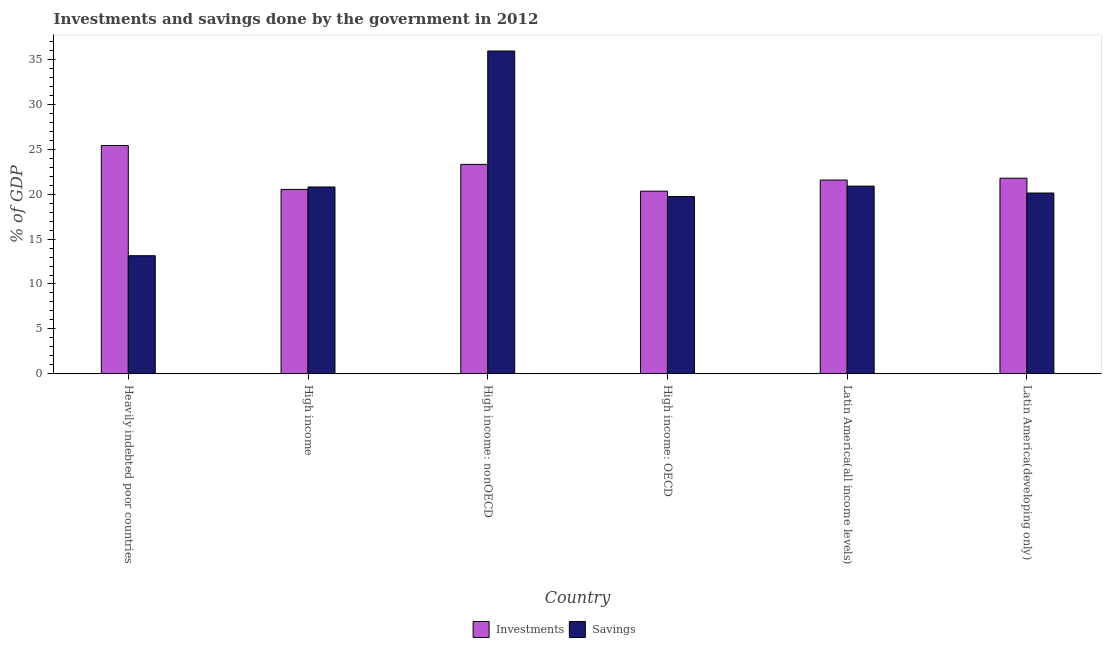Are the number of bars on each tick of the X-axis equal?
Ensure brevity in your answer.  Yes. What is the label of the 6th group of bars from the left?
Provide a succinct answer. Latin America(developing only). What is the investments of government in High income: nonOECD?
Offer a terse response. 23.33. Across all countries, what is the maximum investments of government?
Provide a short and direct response. 25.43. Across all countries, what is the minimum savings of government?
Your response must be concise. 13.15. In which country was the savings of government maximum?
Offer a very short reply. High income: nonOECD. In which country was the savings of government minimum?
Ensure brevity in your answer.  Heavily indebted poor countries. What is the total investments of government in the graph?
Your response must be concise. 133.02. What is the difference between the investments of government in High income and that in Latin America(all income levels)?
Give a very brief answer. -1.04. What is the difference between the investments of government in Heavily indebted poor countries and the savings of government in High income?
Ensure brevity in your answer.  4.62. What is the average investments of government per country?
Your answer should be compact. 22.17. What is the difference between the investments of government and savings of government in Heavily indebted poor countries?
Ensure brevity in your answer.  12.28. What is the ratio of the investments of government in Latin America(all income levels) to that in Latin America(developing only)?
Provide a short and direct response. 0.99. Is the savings of government in Heavily indebted poor countries less than that in High income?
Your response must be concise. Yes. Is the difference between the investments of government in Heavily indebted poor countries and High income: nonOECD greater than the difference between the savings of government in Heavily indebted poor countries and High income: nonOECD?
Make the answer very short. Yes. What is the difference between the highest and the second highest savings of government?
Your response must be concise. 15.06. What is the difference between the highest and the lowest savings of government?
Your response must be concise. 22.81. In how many countries, is the investments of government greater than the average investments of government taken over all countries?
Offer a very short reply. 2. What does the 2nd bar from the left in Latin America(developing only) represents?
Your answer should be compact. Savings. What does the 1st bar from the right in Latin America(all income levels) represents?
Your answer should be compact. Savings. What is the difference between two consecutive major ticks on the Y-axis?
Make the answer very short. 5. Does the graph contain grids?
Provide a short and direct response. No. How are the legend labels stacked?
Ensure brevity in your answer.  Horizontal. What is the title of the graph?
Your response must be concise. Investments and savings done by the government in 2012. What is the label or title of the Y-axis?
Offer a terse response. % of GDP. What is the % of GDP in Investments in Heavily indebted poor countries?
Offer a very short reply. 25.43. What is the % of GDP of Savings in Heavily indebted poor countries?
Keep it short and to the point. 13.15. What is the % of GDP of Investments in High income?
Give a very brief answer. 20.54. What is the % of GDP of Savings in High income?
Your answer should be compact. 20.81. What is the % of GDP in Investments in High income: nonOECD?
Provide a succinct answer. 23.33. What is the % of GDP of Savings in High income: nonOECD?
Make the answer very short. 35.96. What is the % of GDP of Investments in High income: OECD?
Ensure brevity in your answer.  20.34. What is the % of GDP of Savings in High income: OECD?
Keep it short and to the point. 19.74. What is the % of GDP of Investments in Latin America(all income levels)?
Make the answer very short. 21.58. What is the % of GDP of Savings in Latin America(all income levels)?
Offer a very short reply. 20.91. What is the % of GDP in Investments in Latin America(developing only)?
Provide a short and direct response. 21.79. What is the % of GDP in Savings in Latin America(developing only)?
Give a very brief answer. 20.14. Across all countries, what is the maximum % of GDP in Investments?
Keep it short and to the point. 25.43. Across all countries, what is the maximum % of GDP in Savings?
Your response must be concise. 35.96. Across all countries, what is the minimum % of GDP of Investments?
Give a very brief answer. 20.34. Across all countries, what is the minimum % of GDP in Savings?
Make the answer very short. 13.15. What is the total % of GDP in Investments in the graph?
Provide a short and direct response. 133.02. What is the total % of GDP in Savings in the graph?
Your answer should be very brief. 130.71. What is the difference between the % of GDP in Investments in Heavily indebted poor countries and that in High income?
Your answer should be very brief. 4.89. What is the difference between the % of GDP of Savings in Heavily indebted poor countries and that in High income?
Ensure brevity in your answer.  -7.66. What is the difference between the % of GDP of Investments in Heavily indebted poor countries and that in High income: nonOECD?
Provide a short and direct response. 2.1. What is the difference between the % of GDP in Savings in Heavily indebted poor countries and that in High income: nonOECD?
Make the answer very short. -22.81. What is the difference between the % of GDP in Investments in Heavily indebted poor countries and that in High income: OECD?
Offer a terse response. 5.09. What is the difference between the % of GDP in Savings in Heavily indebted poor countries and that in High income: OECD?
Your answer should be very brief. -6.59. What is the difference between the % of GDP in Investments in Heavily indebted poor countries and that in Latin America(all income levels)?
Keep it short and to the point. 3.85. What is the difference between the % of GDP of Savings in Heavily indebted poor countries and that in Latin America(all income levels)?
Provide a succinct answer. -7.75. What is the difference between the % of GDP in Investments in Heavily indebted poor countries and that in Latin America(developing only)?
Provide a short and direct response. 3.64. What is the difference between the % of GDP in Savings in Heavily indebted poor countries and that in Latin America(developing only)?
Your answer should be very brief. -6.99. What is the difference between the % of GDP of Investments in High income and that in High income: nonOECD?
Offer a terse response. -2.79. What is the difference between the % of GDP in Savings in High income and that in High income: nonOECD?
Your answer should be very brief. -15.15. What is the difference between the % of GDP in Investments in High income and that in High income: OECD?
Give a very brief answer. 0.2. What is the difference between the % of GDP in Savings in High income and that in High income: OECD?
Your answer should be compact. 1.07. What is the difference between the % of GDP in Investments in High income and that in Latin America(all income levels)?
Offer a very short reply. -1.04. What is the difference between the % of GDP in Savings in High income and that in Latin America(all income levels)?
Make the answer very short. -0.1. What is the difference between the % of GDP of Investments in High income and that in Latin America(developing only)?
Provide a short and direct response. -1.25. What is the difference between the % of GDP in Savings in High income and that in Latin America(developing only)?
Offer a very short reply. 0.67. What is the difference between the % of GDP in Investments in High income: nonOECD and that in High income: OECD?
Give a very brief answer. 2.99. What is the difference between the % of GDP of Savings in High income: nonOECD and that in High income: OECD?
Your response must be concise. 16.22. What is the difference between the % of GDP of Investments in High income: nonOECD and that in Latin America(all income levels)?
Ensure brevity in your answer.  1.74. What is the difference between the % of GDP of Savings in High income: nonOECD and that in Latin America(all income levels)?
Your answer should be very brief. 15.06. What is the difference between the % of GDP of Investments in High income: nonOECD and that in Latin America(developing only)?
Offer a terse response. 1.54. What is the difference between the % of GDP of Savings in High income: nonOECD and that in Latin America(developing only)?
Keep it short and to the point. 15.82. What is the difference between the % of GDP in Investments in High income: OECD and that in Latin America(all income levels)?
Provide a succinct answer. -1.24. What is the difference between the % of GDP of Savings in High income: OECD and that in Latin America(all income levels)?
Give a very brief answer. -1.16. What is the difference between the % of GDP in Investments in High income: OECD and that in Latin America(developing only)?
Keep it short and to the point. -1.45. What is the difference between the % of GDP of Savings in High income: OECD and that in Latin America(developing only)?
Keep it short and to the point. -0.4. What is the difference between the % of GDP in Investments in Latin America(all income levels) and that in Latin America(developing only)?
Ensure brevity in your answer.  -0.2. What is the difference between the % of GDP of Savings in Latin America(all income levels) and that in Latin America(developing only)?
Ensure brevity in your answer.  0.77. What is the difference between the % of GDP in Investments in Heavily indebted poor countries and the % of GDP in Savings in High income?
Offer a very short reply. 4.62. What is the difference between the % of GDP in Investments in Heavily indebted poor countries and the % of GDP in Savings in High income: nonOECD?
Your response must be concise. -10.53. What is the difference between the % of GDP of Investments in Heavily indebted poor countries and the % of GDP of Savings in High income: OECD?
Your answer should be compact. 5.69. What is the difference between the % of GDP of Investments in Heavily indebted poor countries and the % of GDP of Savings in Latin America(all income levels)?
Your answer should be compact. 4.53. What is the difference between the % of GDP of Investments in Heavily indebted poor countries and the % of GDP of Savings in Latin America(developing only)?
Provide a succinct answer. 5.29. What is the difference between the % of GDP of Investments in High income and the % of GDP of Savings in High income: nonOECD?
Your answer should be compact. -15.42. What is the difference between the % of GDP of Investments in High income and the % of GDP of Savings in High income: OECD?
Your response must be concise. 0.8. What is the difference between the % of GDP in Investments in High income and the % of GDP in Savings in Latin America(all income levels)?
Offer a terse response. -0.37. What is the difference between the % of GDP of Investments in High income and the % of GDP of Savings in Latin America(developing only)?
Ensure brevity in your answer.  0.4. What is the difference between the % of GDP in Investments in High income: nonOECD and the % of GDP in Savings in High income: OECD?
Keep it short and to the point. 3.59. What is the difference between the % of GDP in Investments in High income: nonOECD and the % of GDP in Savings in Latin America(all income levels)?
Give a very brief answer. 2.42. What is the difference between the % of GDP in Investments in High income: nonOECD and the % of GDP in Savings in Latin America(developing only)?
Provide a short and direct response. 3.19. What is the difference between the % of GDP in Investments in High income: OECD and the % of GDP in Savings in Latin America(all income levels)?
Your answer should be compact. -0.56. What is the difference between the % of GDP in Investments in High income: OECD and the % of GDP in Savings in Latin America(developing only)?
Your answer should be compact. 0.21. What is the difference between the % of GDP of Investments in Latin America(all income levels) and the % of GDP of Savings in Latin America(developing only)?
Ensure brevity in your answer.  1.45. What is the average % of GDP of Investments per country?
Offer a terse response. 22.17. What is the average % of GDP of Savings per country?
Provide a succinct answer. 21.78. What is the difference between the % of GDP of Investments and % of GDP of Savings in Heavily indebted poor countries?
Your answer should be very brief. 12.28. What is the difference between the % of GDP in Investments and % of GDP in Savings in High income?
Give a very brief answer. -0.27. What is the difference between the % of GDP in Investments and % of GDP in Savings in High income: nonOECD?
Keep it short and to the point. -12.63. What is the difference between the % of GDP in Investments and % of GDP in Savings in High income: OECD?
Give a very brief answer. 0.6. What is the difference between the % of GDP in Investments and % of GDP in Savings in Latin America(all income levels)?
Give a very brief answer. 0.68. What is the difference between the % of GDP in Investments and % of GDP in Savings in Latin America(developing only)?
Provide a succinct answer. 1.65. What is the ratio of the % of GDP in Investments in Heavily indebted poor countries to that in High income?
Your response must be concise. 1.24. What is the ratio of the % of GDP in Savings in Heavily indebted poor countries to that in High income?
Provide a short and direct response. 0.63. What is the ratio of the % of GDP of Investments in Heavily indebted poor countries to that in High income: nonOECD?
Provide a succinct answer. 1.09. What is the ratio of the % of GDP in Savings in Heavily indebted poor countries to that in High income: nonOECD?
Give a very brief answer. 0.37. What is the ratio of the % of GDP of Investments in Heavily indebted poor countries to that in High income: OECD?
Provide a succinct answer. 1.25. What is the ratio of the % of GDP in Savings in Heavily indebted poor countries to that in High income: OECD?
Keep it short and to the point. 0.67. What is the ratio of the % of GDP in Investments in Heavily indebted poor countries to that in Latin America(all income levels)?
Your response must be concise. 1.18. What is the ratio of the % of GDP in Savings in Heavily indebted poor countries to that in Latin America(all income levels)?
Offer a very short reply. 0.63. What is the ratio of the % of GDP in Investments in Heavily indebted poor countries to that in Latin America(developing only)?
Your answer should be very brief. 1.17. What is the ratio of the % of GDP in Savings in Heavily indebted poor countries to that in Latin America(developing only)?
Provide a short and direct response. 0.65. What is the ratio of the % of GDP in Investments in High income to that in High income: nonOECD?
Provide a short and direct response. 0.88. What is the ratio of the % of GDP of Savings in High income to that in High income: nonOECD?
Your answer should be compact. 0.58. What is the ratio of the % of GDP in Investments in High income to that in High income: OECD?
Keep it short and to the point. 1.01. What is the ratio of the % of GDP in Savings in High income to that in High income: OECD?
Ensure brevity in your answer.  1.05. What is the ratio of the % of GDP in Investments in High income to that in Latin America(all income levels)?
Ensure brevity in your answer.  0.95. What is the ratio of the % of GDP in Investments in High income to that in Latin America(developing only)?
Your answer should be very brief. 0.94. What is the ratio of the % of GDP of Investments in High income: nonOECD to that in High income: OECD?
Offer a terse response. 1.15. What is the ratio of the % of GDP in Savings in High income: nonOECD to that in High income: OECD?
Your answer should be compact. 1.82. What is the ratio of the % of GDP in Investments in High income: nonOECD to that in Latin America(all income levels)?
Ensure brevity in your answer.  1.08. What is the ratio of the % of GDP of Savings in High income: nonOECD to that in Latin America(all income levels)?
Your answer should be compact. 1.72. What is the ratio of the % of GDP of Investments in High income: nonOECD to that in Latin America(developing only)?
Ensure brevity in your answer.  1.07. What is the ratio of the % of GDP of Savings in High income: nonOECD to that in Latin America(developing only)?
Provide a succinct answer. 1.79. What is the ratio of the % of GDP in Investments in High income: OECD to that in Latin America(all income levels)?
Keep it short and to the point. 0.94. What is the ratio of the % of GDP in Savings in High income: OECD to that in Latin America(all income levels)?
Your answer should be compact. 0.94. What is the ratio of the % of GDP in Investments in High income: OECD to that in Latin America(developing only)?
Give a very brief answer. 0.93. What is the ratio of the % of GDP of Savings in High income: OECD to that in Latin America(developing only)?
Your answer should be very brief. 0.98. What is the ratio of the % of GDP in Investments in Latin America(all income levels) to that in Latin America(developing only)?
Your answer should be very brief. 0.99. What is the ratio of the % of GDP in Savings in Latin America(all income levels) to that in Latin America(developing only)?
Offer a terse response. 1.04. What is the difference between the highest and the second highest % of GDP in Investments?
Provide a succinct answer. 2.1. What is the difference between the highest and the second highest % of GDP of Savings?
Your answer should be very brief. 15.06. What is the difference between the highest and the lowest % of GDP of Investments?
Provide a succinct answer. 5.09. What is the difference between the highest and the lowest % of GDP in Savings?
Offer a very short reply. 22.81. 